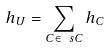Convert formula to latex. <formula><loc_0><loc_0><loc_500><loc_500>h _ { U } = \sum _ { C \in \ s C } h _ { C }</formula> 